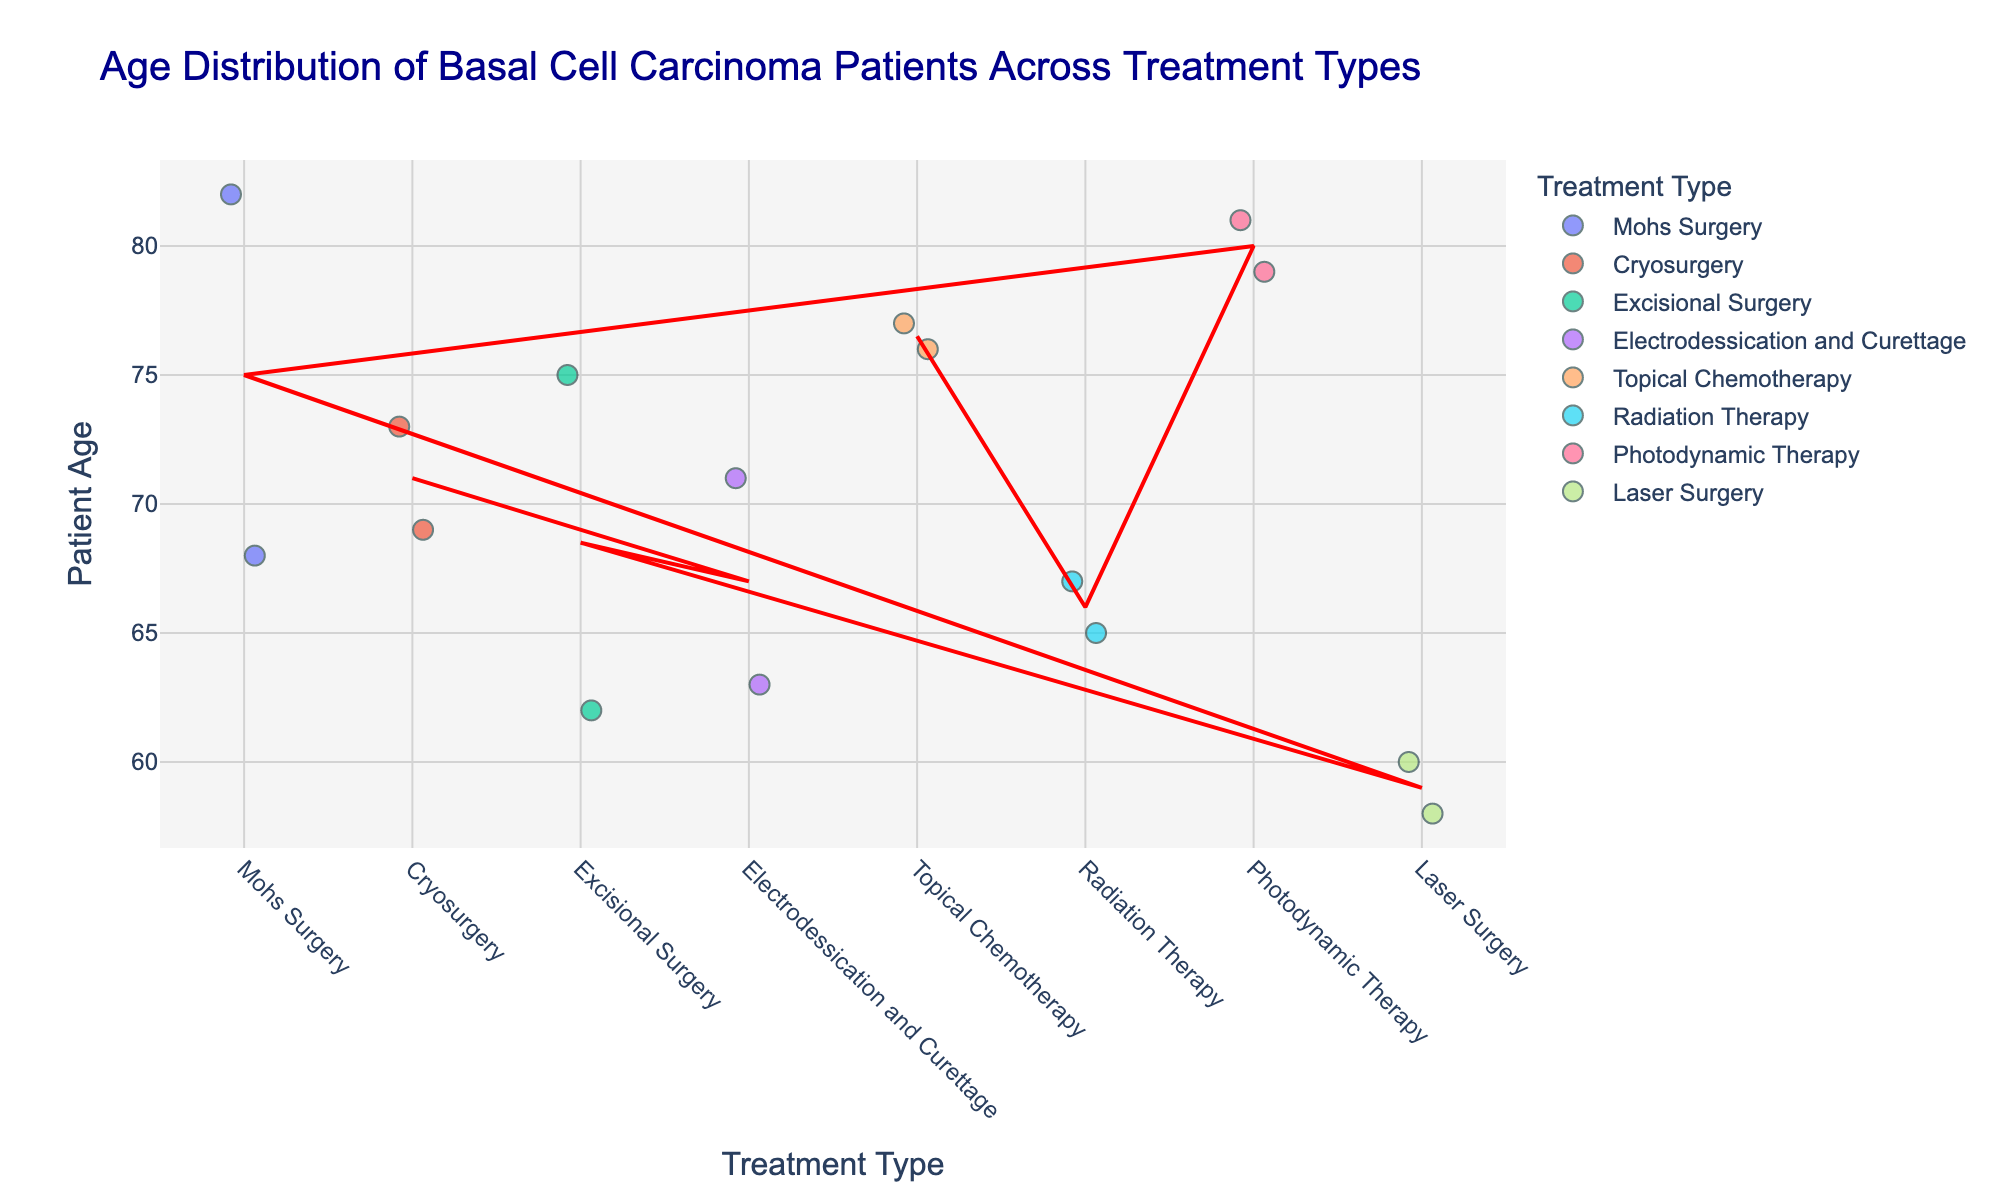How many different treatment types are presented in the plot? Look at the x-axis labels to count the different treatment types listed. There are eight different treatments shown: Mohs Surgery, Cryosurgery, Excisional Surgery, Electrodessication and Curettage, Topical Chemotherapy, Radiation Therapy, Photodynamic Therapy, and Laser Surgery.
Answer: 8 What is the title of the plot? The title of the plot is usually found at the top of the figure. In this case, it reads "Age Distribution of Basal Cell Carcinoma Patients Across Treatment Types".
Answer: Age Distribution of Basal Cell Carcinoma Patients Across Treatment Types Which treatment has the highest average age of patients? The average age line, which is depicted by a red line for each treatment, is used to determine the highest average age. The treatment with the highest point on this line indicates the highest average age.
Answer: Photodynamic Therapy Which treatment type shows the widest age range among patients? Observe the spread of the dots along the y-axis for each treatment type. The treatment with the widest spread of ages from the lowest to the highest value will have the widest age range.
Answer: Mohs Surgery Which treatment has the oldest patient in the data? Scan the y-axis to find the highest age value and then trace it to the corresponding treatment. The oldest age visible is 82 under Mohs Surgery.
Answer: Mohs Surgery What is the average age of patients undergoing Mohs Surgery? Follow the red average age line for Mohs Surgery to its intersection with the y-axis. Based on the point where it intersects, it appears to be around 75.
Answer: 75 What is the patient count for Electrodessication and Curettage at age 71? Hover over the dot representing age 71 under Electrodessication and Curettage. The hover data will display the patient count for that dot. The patient count is indicated as 29.
Answer: 29 Compare the average ages of patients undergoing Excisional Surgery and Radiation Therapy. Which is higher? Observe the red line indicating the average ages for Excisional Surgery and Radiation Therapy. The average age for Excisional Surgery is around 68, while for Radiation Therapy it is around 66. Therefore, Excisional Surgery has a higher average age than Radiation Therapy.
Answer: Excisional Surgery What is the difference between the average ages of patients undergoing Cryosurgery and Laser Surgery? Determine the average ages for each treatment by looking at the red lines: Cryosurgery's average age is about 71, and Laser Surgery's average age is about 59. Calculate the difference: 71 - 59 = 12.
Answer: 12 Which treatment type shows a patient count of 42 in the data and for which age? Hover over the dots until you find the hover data indicating a patient count of 42. In this dataset, a patient count of 42 is found under Mohs Surgery for the age of 68.
Answer: Mohs Surgery at age 68 